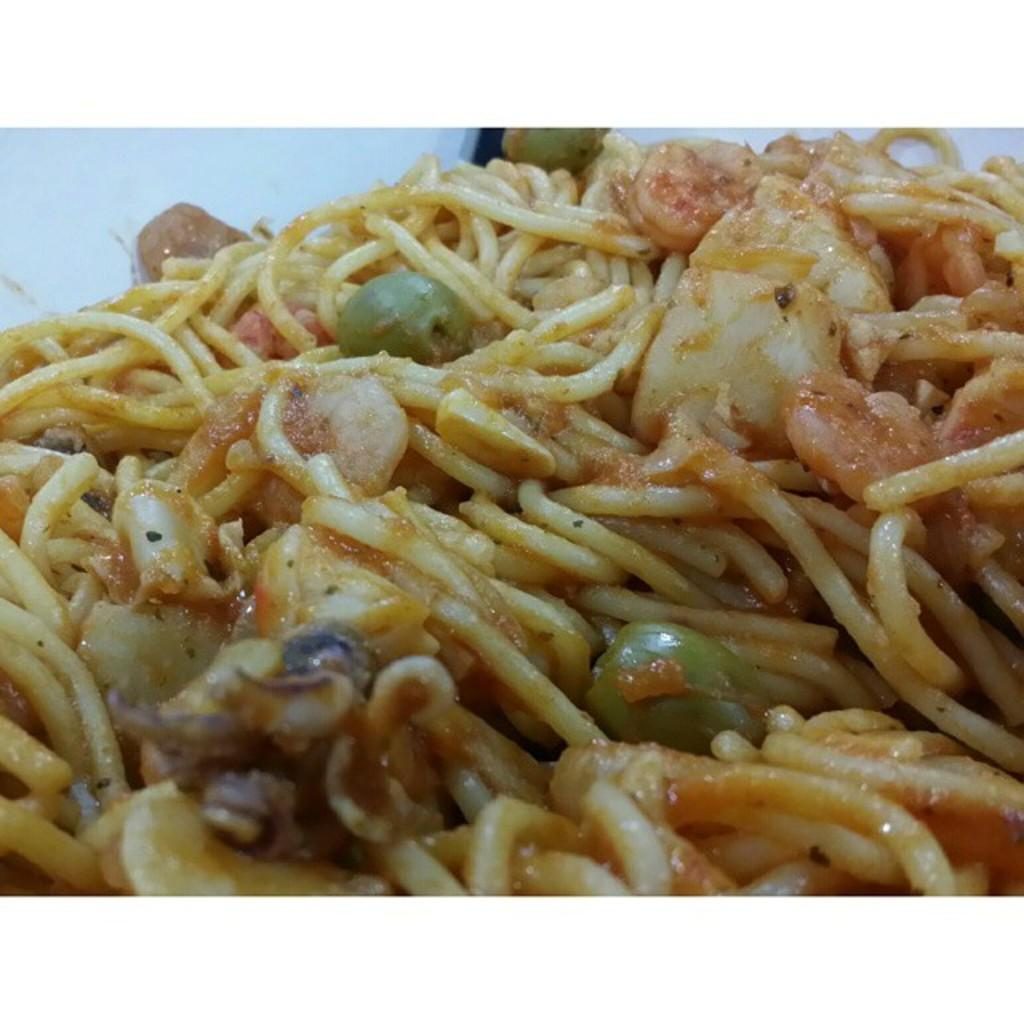What type of food is visible in the image? There are noodles in the image. How many branches can be seen in the image? There are no branches present in the image; it only features noodles. What type of note is being played by the flock of birds in the image? There are no birds or notes present in the image; it only features noodles. 